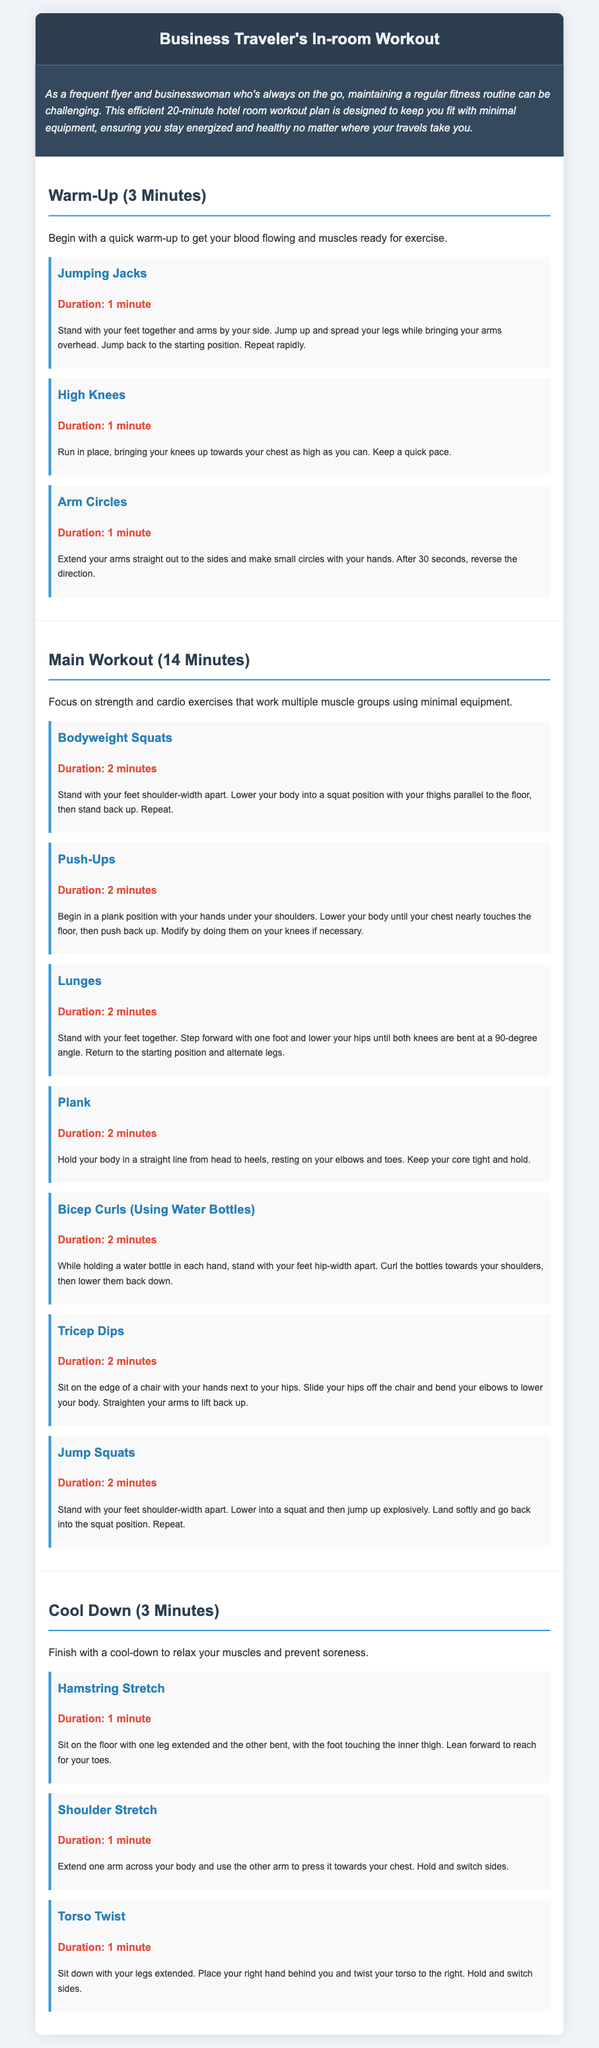What is the total duration of the workout? The total duration includes the warm-up, main workout, and cool down, calculated as 3 minutes + 14 minutes + 3 minutes = 20 minutes.
Answer: 20 minutes How many exercises are in the main workout section? There are 7 exercises listed under the main workout section.
Answer: 7 exercises What exercise uses water bottles? The exercise specifically mentioned for water bottles is Bicep Curls.
Answer: Bicep Curls What is the duration of the Jumping Jacks exercise? The document states that Jumping Jacks have a duration of 1 minute.
Answer: 1 minute What is the main focus of the workout? The main focus of the workout is on strength and cardio exercises.
Answer: Strength and cardio exercises How long should the Plank exercise be held? The duration for holding the Plank exercise is 2 minutes.
Answer: 2 minutes What should you do during the Hamstring Stretch? The action during the Hamstring Stretch is to sit and lean forward to reach for your toes.
Answer: Reach for your toes What type of workout plan is this document focused on? The document is focused on an in-room workout plan for business travelers.
Answer: In-room workout plan 